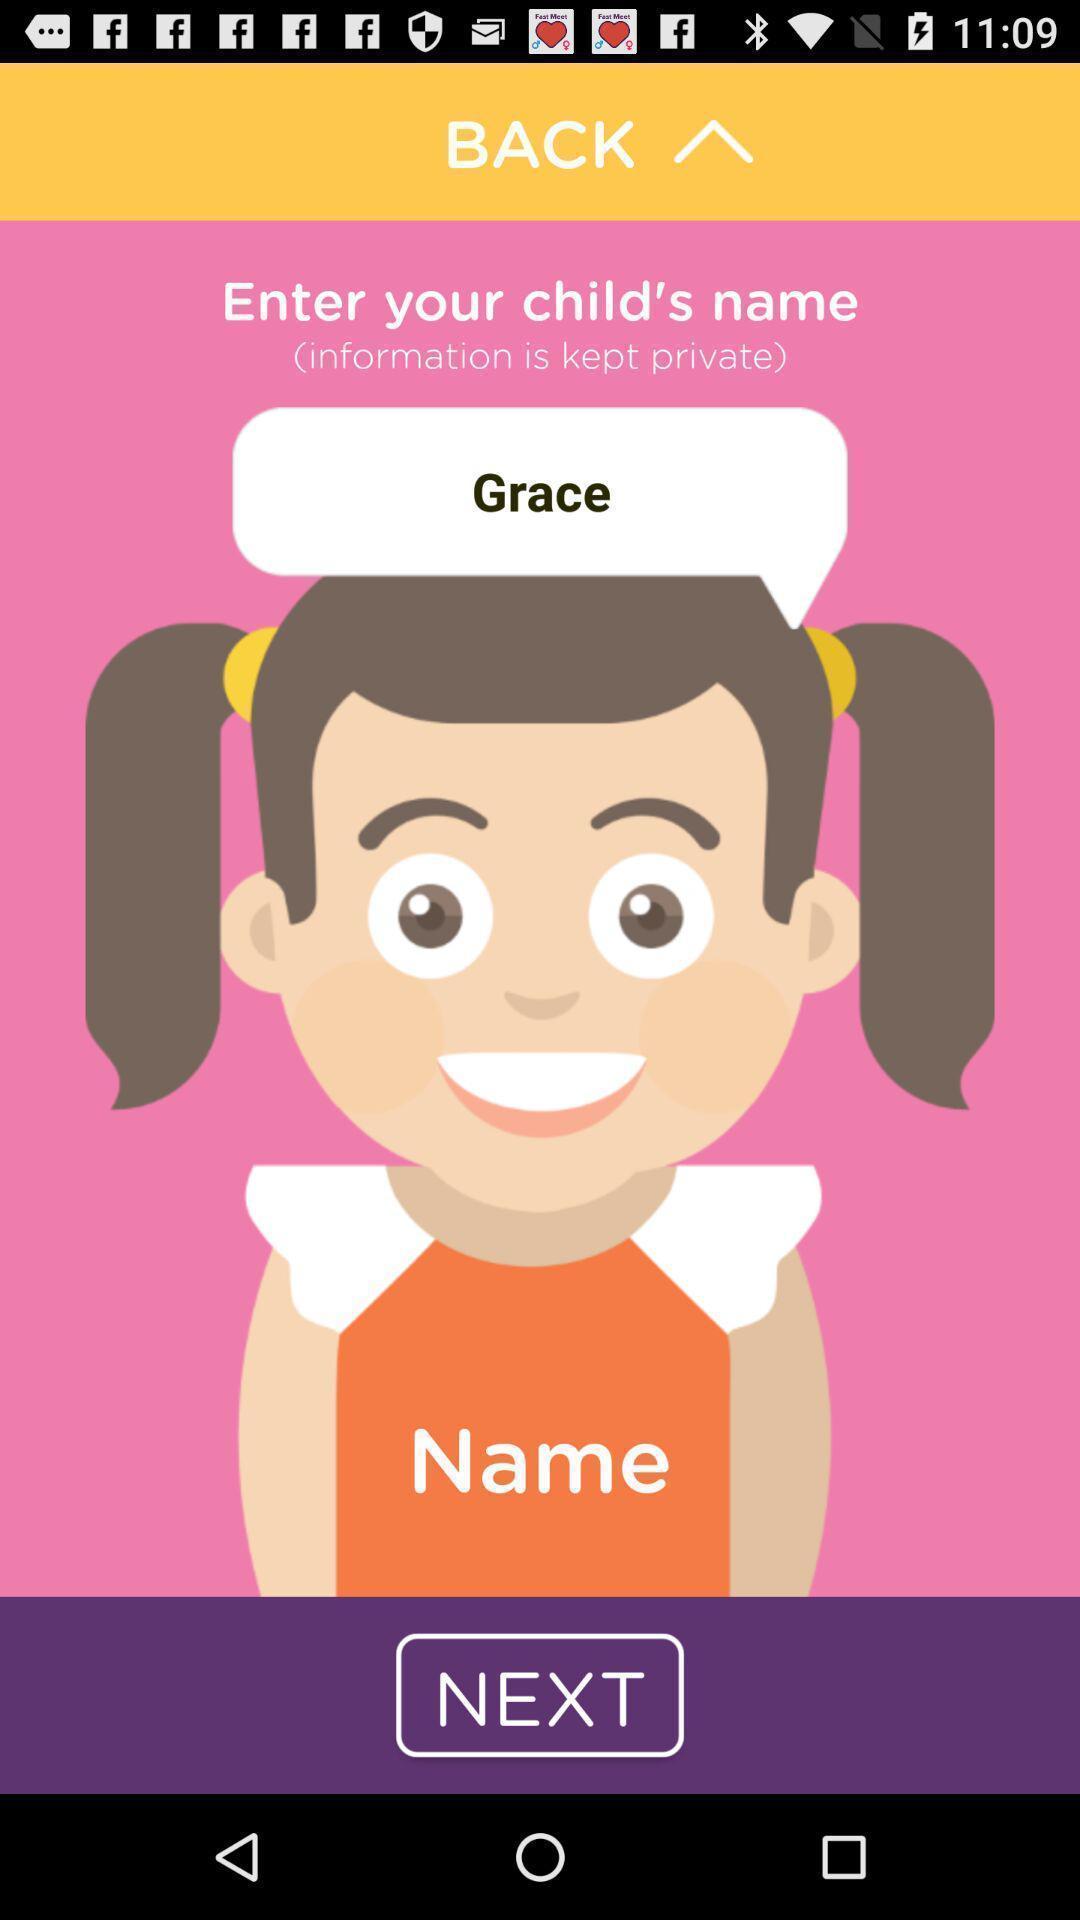Summarize the information in this screenshot. Screen showing to enter your child name option. 